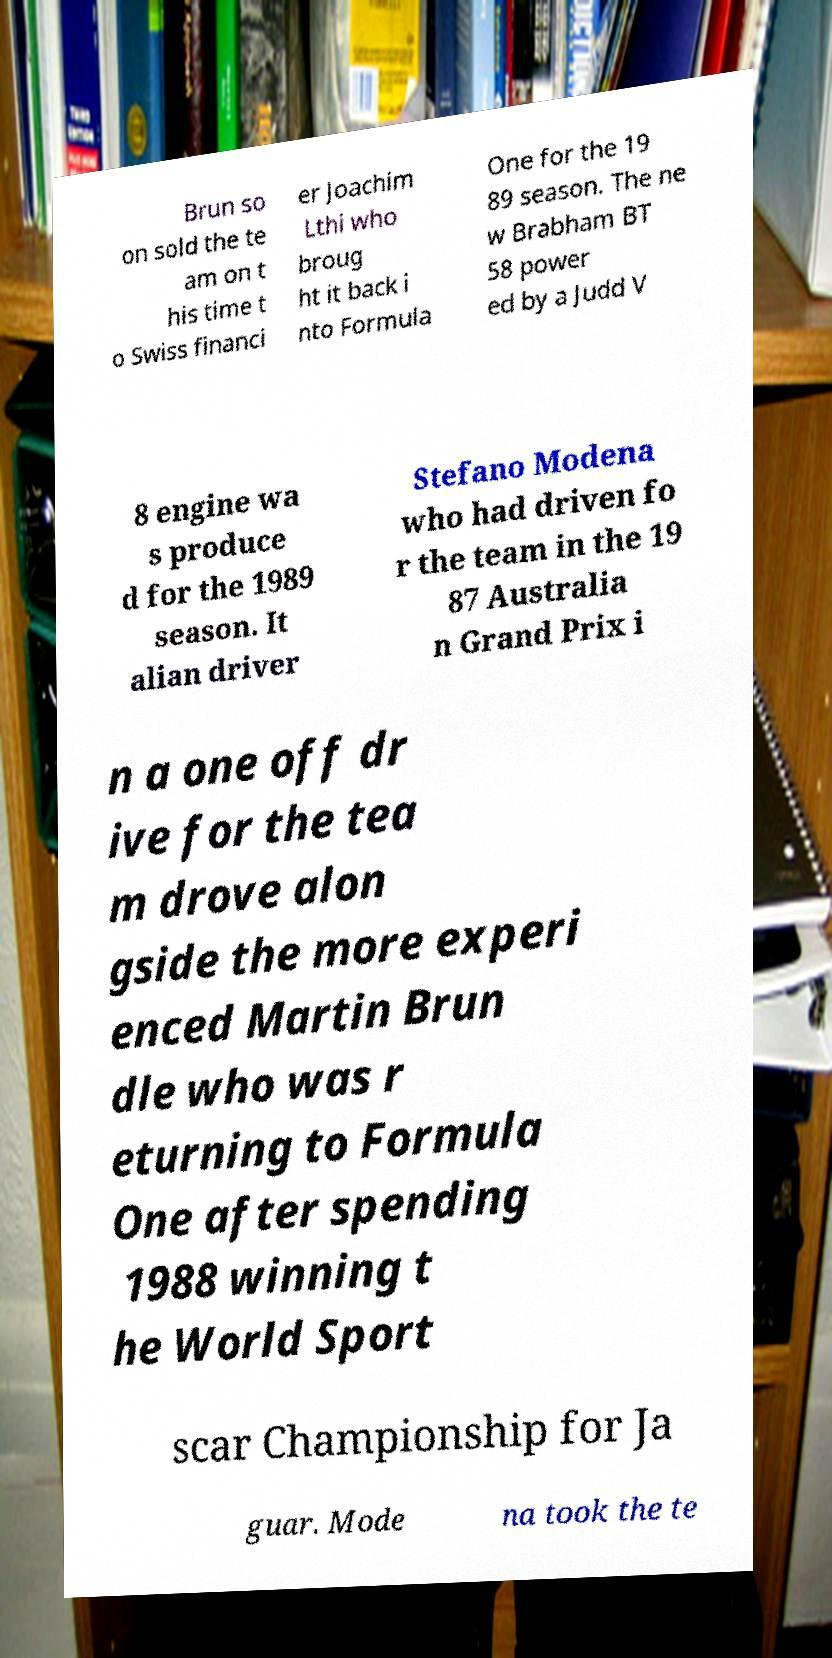Could you assist in decoding the text presented in this image and type it out clearly? Brun so on sold the te am on t his time t o Swiss financi er Joachim Lthi who broug ht it back i nto Formula One for the 19 89 season. The ne w Brabham BT 58 power ed by a Judd V 8 engine wa s produce d for the 1989 season. It alian driver Stefano Modena who had driven fo r the team in the 19 87 Australia n Grand Prix i n a one off dr ive for the tea m drove alon gside the more experi enced Martin Brun dle who was r eturning to Formula One after spending 1988 winning t he World Sport scar Championship for Ja guar. Mode na took the te 